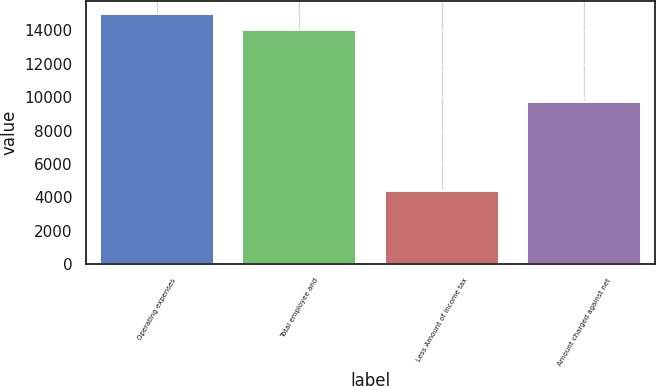Convert chart to OTSL. <chart><loc_0><loc_0><loc_500><loc_500><bar_chart><fcel>Operating expenses<fcel>Total employee and<fcel>Less Amount of income tax<fcel>Amount charged against net<nl><fcel>15008.3<fcel>14040<fcel>4358<fcel>9682<nl></chart> 